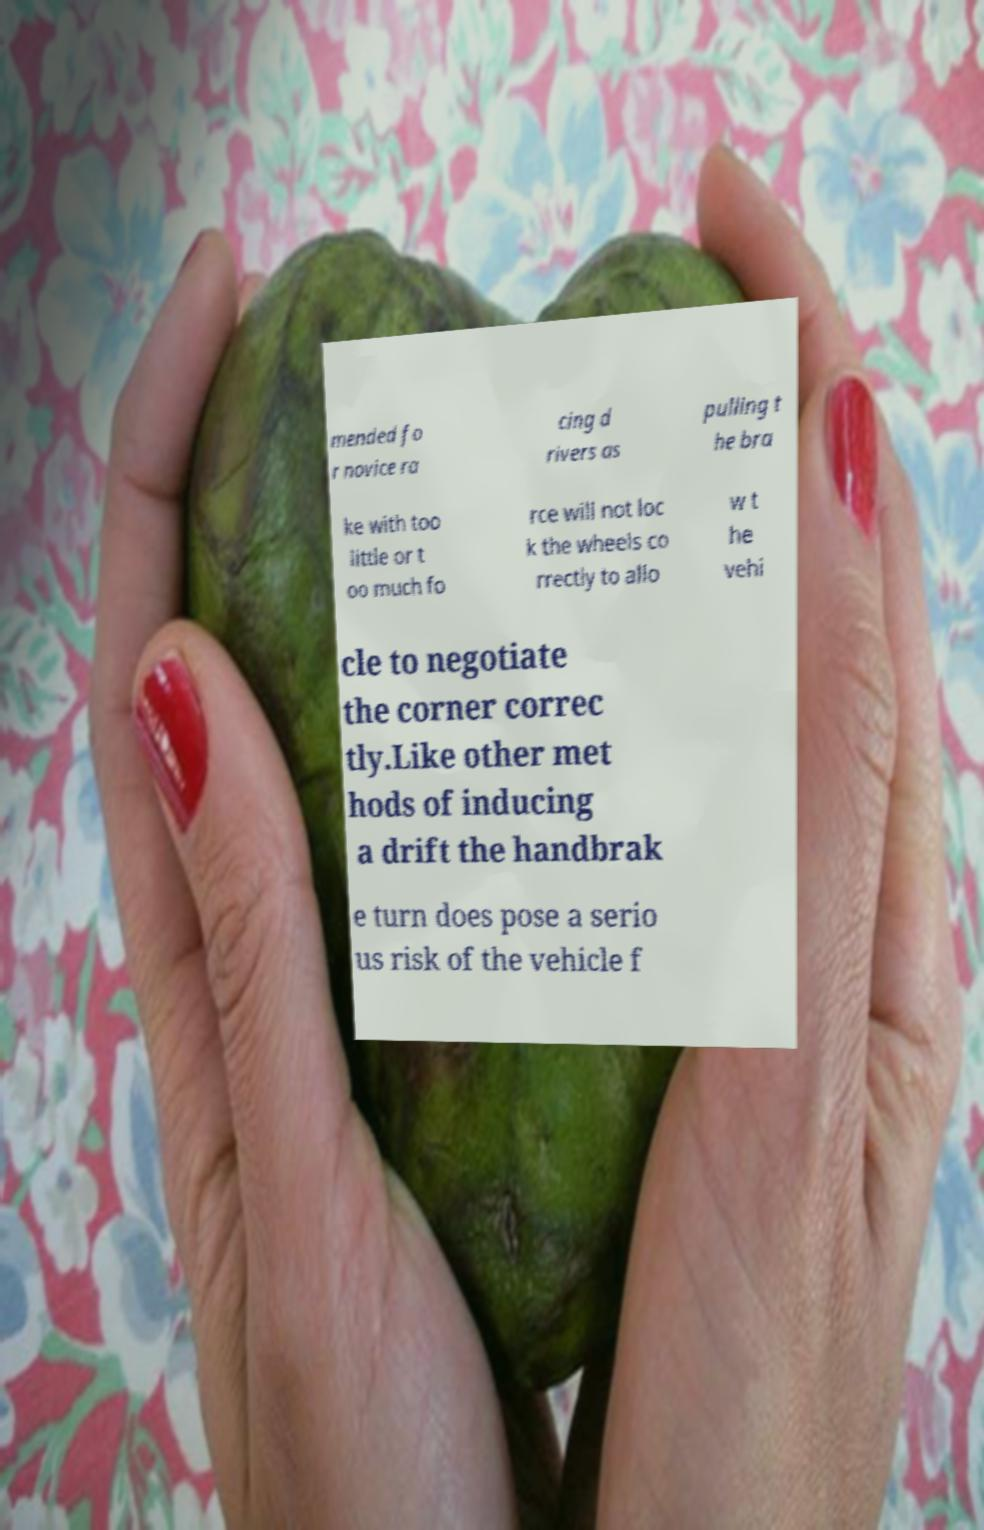Please identify and transcribe the text found in this image. mended fo r novice ra cing d rivers as pulling t he bra ke with too little or t oo much fo rce will not loc k the wheels co rrectly to allo w t he vehi cle to negotiate the corner correc tly.Like other met hods of inducing a drift the handbrak e turn does pose a serio us risk of the vehicle f 